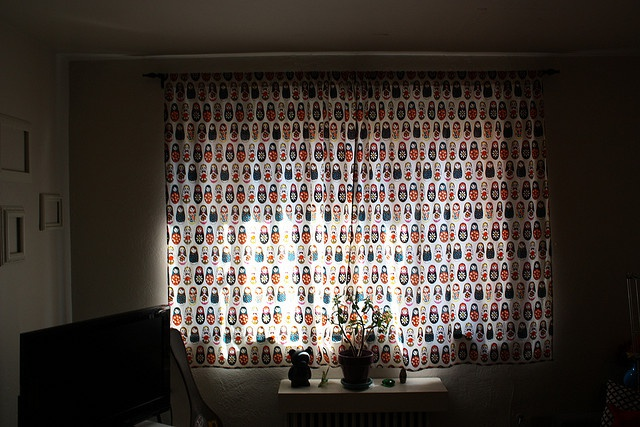Describe the objects in this image and their specific colors. I can see tv in black, gray, and darkgray tones, potted plant in black, white, gray, and darkgray tones, tennis racket in black and salmon tones, and teddy bear in black, gray, maroon, and white tones in this image. 